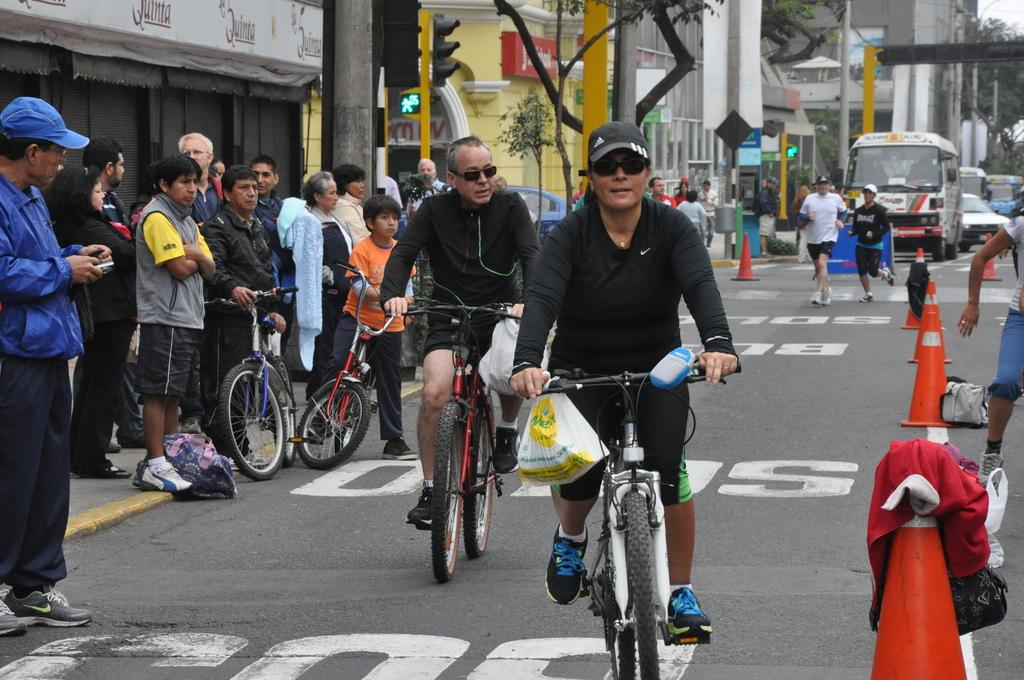How many people are riding a bicycle in the image? There are two people riding a bicycle in the image. What are the other people in the image doing? There are two people running on the road in the image, and there are people standing to the side. What is happening on the road in the image? Vehicles are moving on the road in the image. How many girls are playing in the sand in the image? There is no sand or girls present in the image. What type of crowd can be seen gathering around the people standing to the side in the image? There is no crowd present in the image; only a few people are standing to the side. 